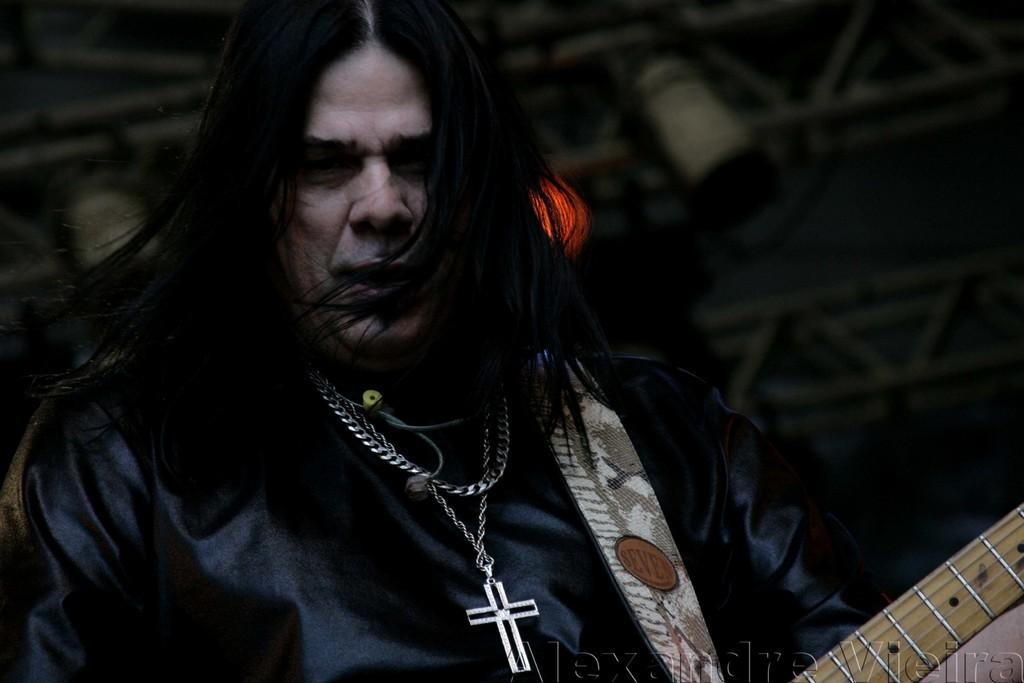Who or what is the main subject in the image? There is a person in the image. What is the person wearing in the image? The person is wearing a black color jacket. What is the person holding in the image? The person is holding a guitar in their hands. Can you describe any accessories the person is wearing in the image? The person is wearing a locket around their neck. How does the earthquake affect the person in the image? There is no earthquake present in the image, so its effect on the person cannot be determined. What type of glove is the person wearing in the image? There is no glove visible in the image; the person is wearing a black jacket and holding a guitar. 